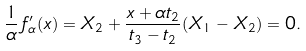Convert formula to latex. <formula><loc_0><loc_0><loc_500><loc_500>\frac { 1 } { \alpha } \, f ^ { \prime } _ { \alpha } ( x ) = X _ { 2 } + \frac { x + \alpha t _ { 2 } } { t _ { 3 } - t _ { 2 } } ( X _ { 1 } - X _ { 2 } ) = 0 .</formula> 